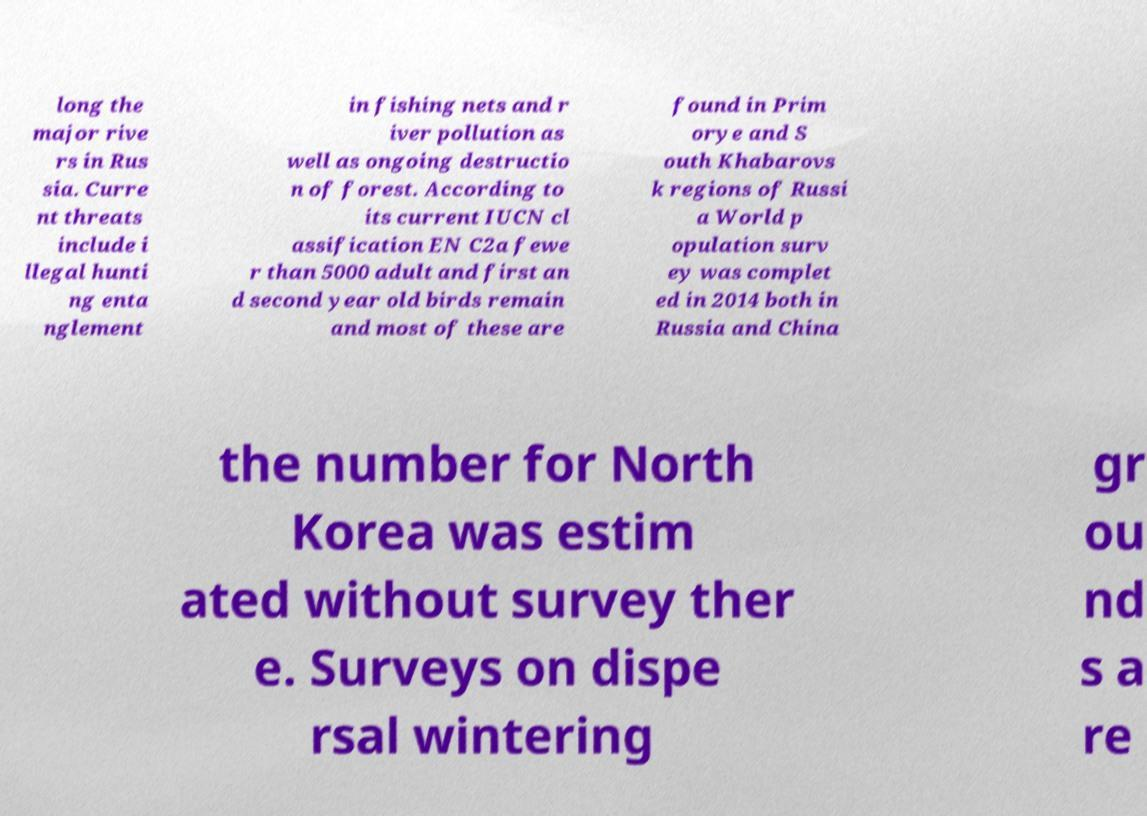For documentation purposes, I need the text within this image transcribed. Could you provide that? long the major rive rs in Rus sia. Curre nt threats include i llegal hunti ng enta nglement in fishing nets and r iver pollution as well as ongoing destructio n of forest. According to its current IUCN cl assification EN C2a fewe r than 5000 adult and first an d second year old birds remain and most of these are found in Prim orye and S outh Khabarovs k regions of Russi a World p opulation surv ey was complet ed in 2014 both in Russia and China the number for North Korea was estim ated without survey ther e. Surveys on dispe rsal wintering gr ou nd s a re 